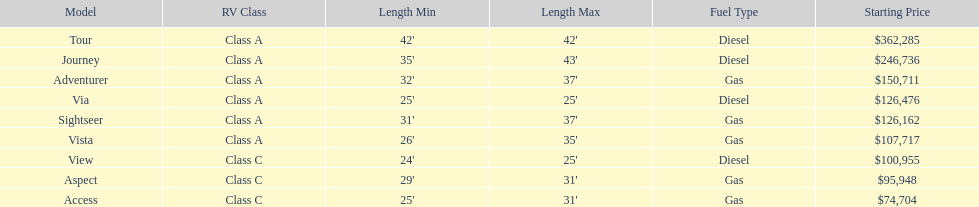What is the total number of class a models? 6. 